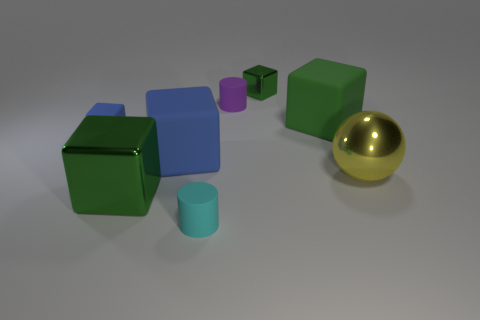Subtract all blue cylinders. How many green cubes are left? 3 Subtract all tiny metal blocks. How many blocks are left? 4 Subtract all gray cubes. Subtract all red cylinders. How many cubes are left? 5 Add 2 big spheres. How many objects exist? 10 Subtract all spheres. How many objects are left? 7 Subtract all small rubber things. Subtract all tiny blue rubber objects. How many objects are left? 4 Add 5 tiny cyan cylinders. How many tiny cyan cylinders are left? 6 Add 5 green metal things. How many green metal things exist? 7 Subtract 1 yellow balls. How many objects are left? 7 